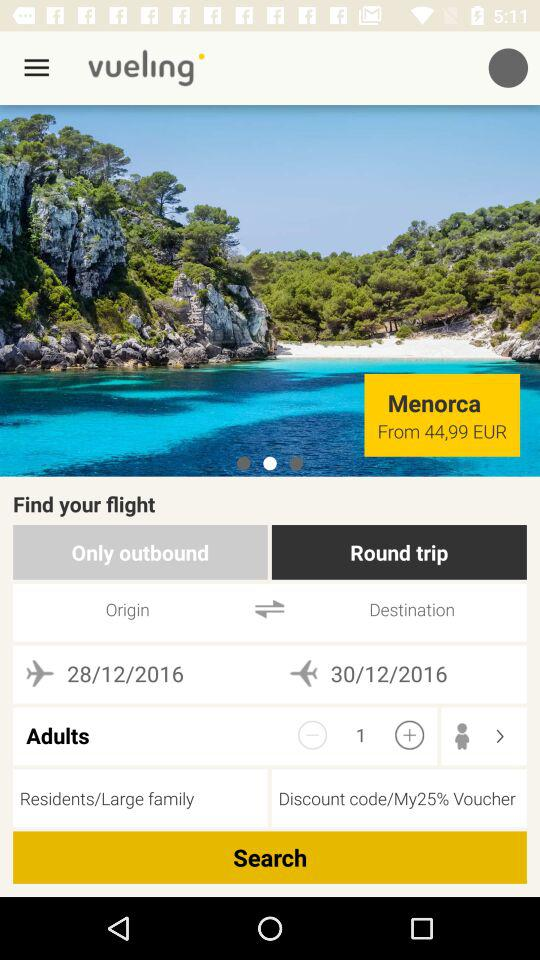How many adults are flying?
Answer the question using a single word or phrase. 1 